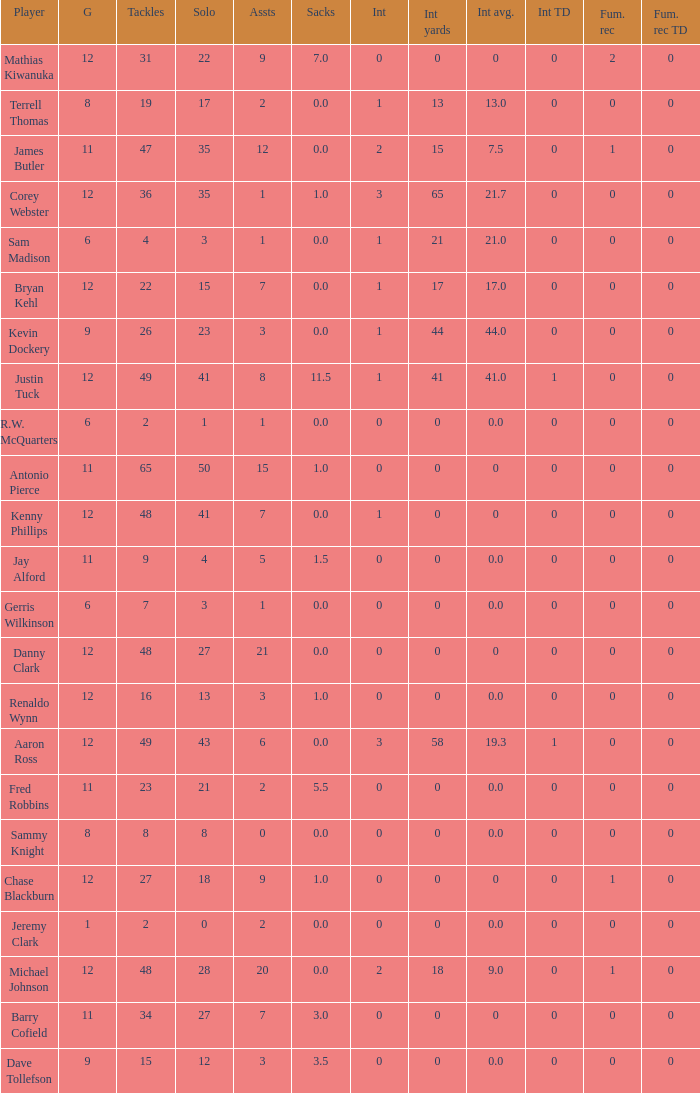Name the least fum rec td 0.0. 